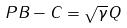Convert formula to latex. <formula><loc_0><loc_0><loc_500><loc_500>P B - C = \sqrt { \gamma } Q</formula> 